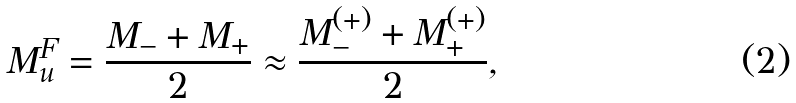Convert formula to latex. <formula><loc_0><loc_0><loc_500><loc_500>M _ { u } ^ { F } = \frac { M _ { - } + M _ { + } } { 2 } \approx \frac { M ^ { ( + ) } _ { - } + M ^ { ( + ) } _ { + } } { 2 } ,</formula> 